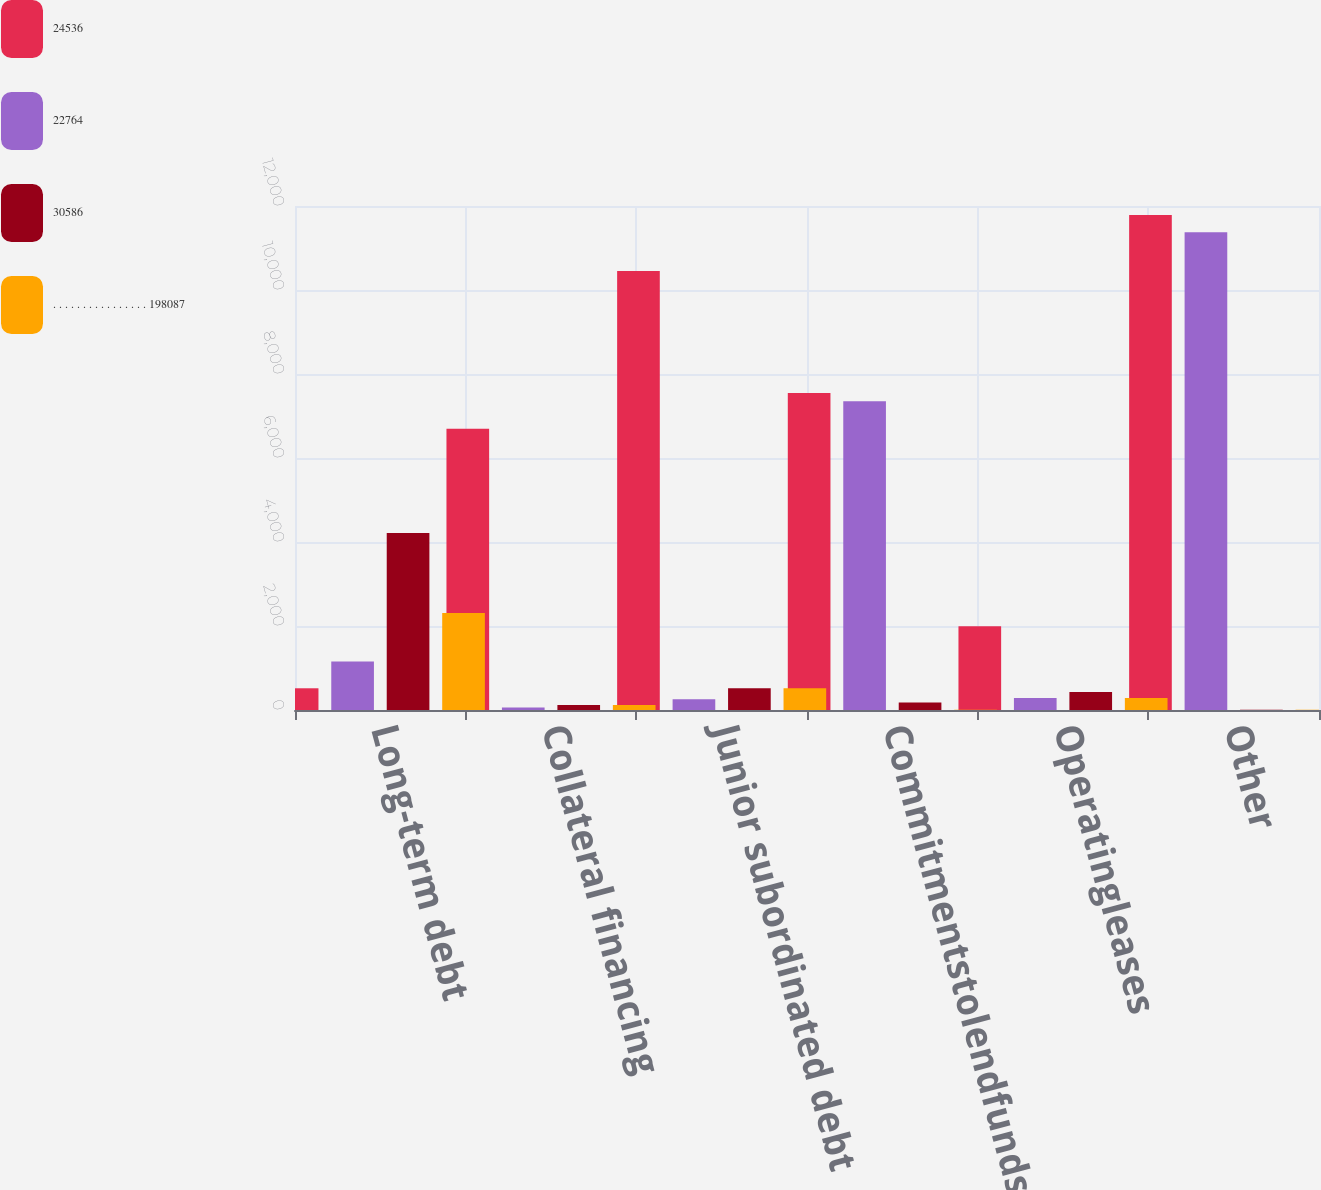<chart> <loc_0><loc_0><loc_500><loc_500><stacked_bar_chart><ecel><fcel>Long-term debt<fcel>Collateral financing<fcel>Junior subordinated debt<fcel>Commitmentstolendfunds<fcel>Operatingleases<fcel>Other<nl><fcel>24536<fcel>517<fcel>6694<fcel>10450<fcel>7549<fcel>1996<fcel>11788<nl><fcel>22764<fcel>1155<fcel>61<fcel>258<fcel>7349<fcel>287<fcel>11374<nl><fcel>30586<fcel>4214<fcel>122<fcel>517<fcel>177<fcel>427<fcel>6<nl><fcel>. . . . . . . . . . . . . . . . 198087<fcel>2312<fcel>122<fcel>517<fcel>4<fcel>288<fcel>6<nl></chart> 